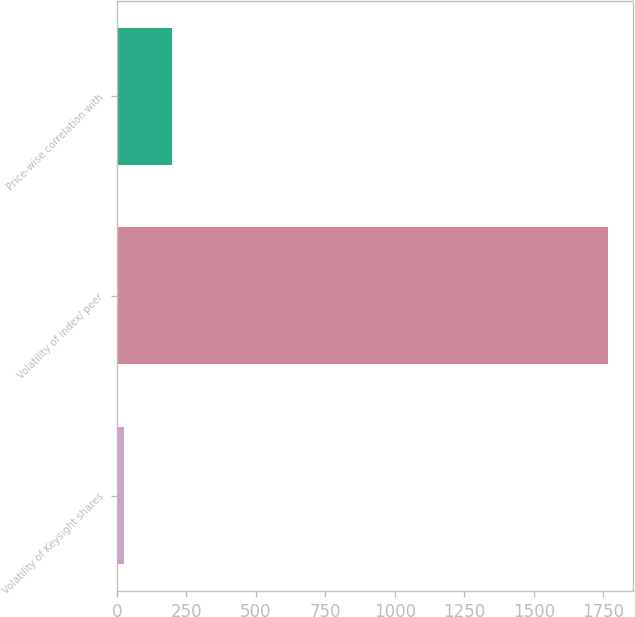<chart> <loc_0><loc_0><loc_500><loc_500><bar_chart><fcel>Volatility of Keysight shares<fcel>Volatility of index/ peer<fcel>Price-wise correlation with<nl><fcel>26<fcel>1767<fcel>200.1<nl></chart> 